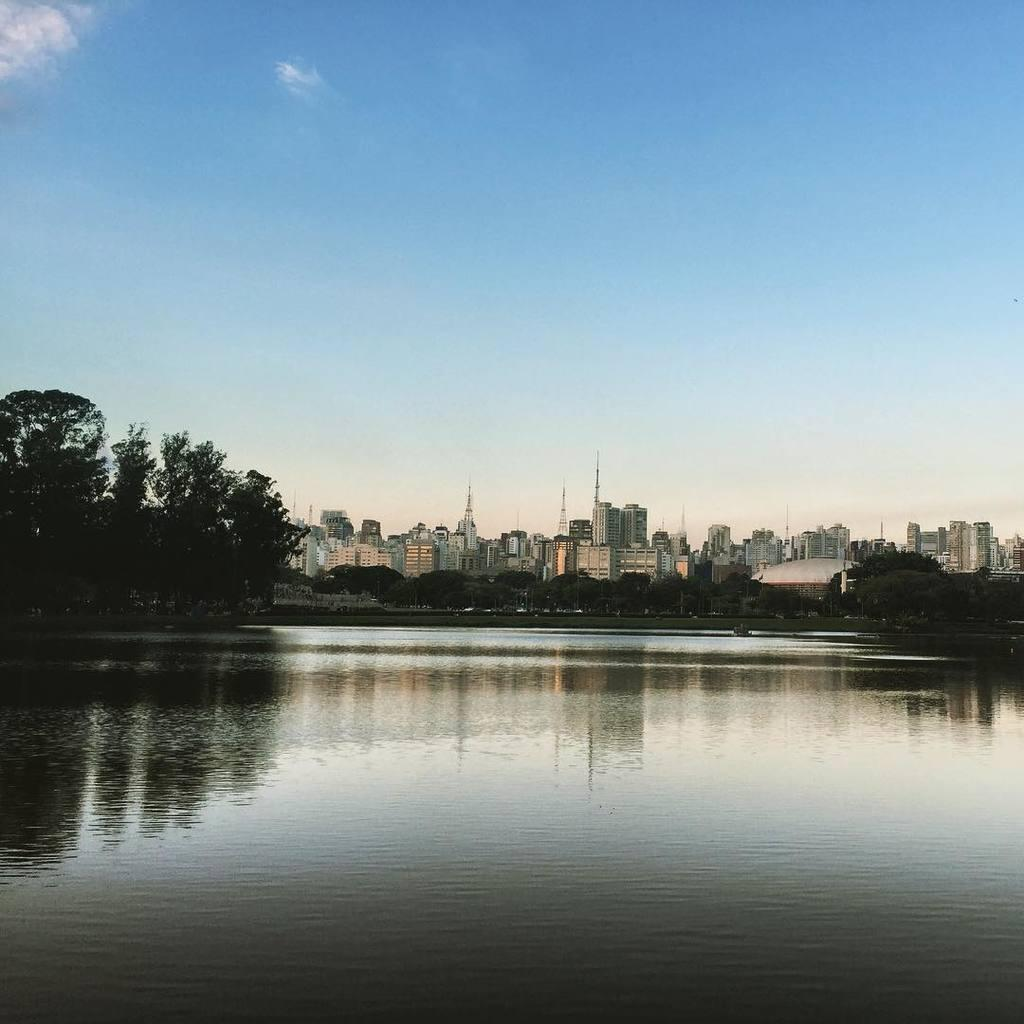What type of natural feature is present in the image? There is a river in the image. What type of man-made structures can be seen in the image? There are many buildings in the image. What type of vegetation is present in the image? There are trees in the image. What color is the sky in the image? The sky is blue in the image. What type of frame is used to display the image? The question refers to the physical frame of the image, not the content of the image itself. Therefore, we cannot answer this question based on the provided facts. --- Facts: 1. There is a car in the image. 2. The car is red. 3. The car has four wheels. 4. There are people in the car. 5. The car is parked on the street. Absurd Topics: dance, ocean, guitar Conversation: What type of vehicle is present in the image? There is a car in the image. What color is the car in the image? The car is red. How many wheels does the car have? The car has four wheels. Are there any passengers in the car? Yes, there are people in the car. Where is the car located in the image? The car is parked on the street. Reasoning: Let's think step by step in order to produce the conversation. We start by identifying the main subject in the image, which is the car. Then, we expand the conversation to include other details about the car, such as its color, number of wheels, and the presence of passengers. Finally, we describe the car's location in the image, which is parked on the street. Each question is designed to elicit a specific detail about the image that is known from the provided facts. Absurd Question/Answer: Can you hear the guitar being played in the car in the image? The question refers to an auditory element that is not present in the image. Therefore, we cannot answer this question based on the provided facts. 